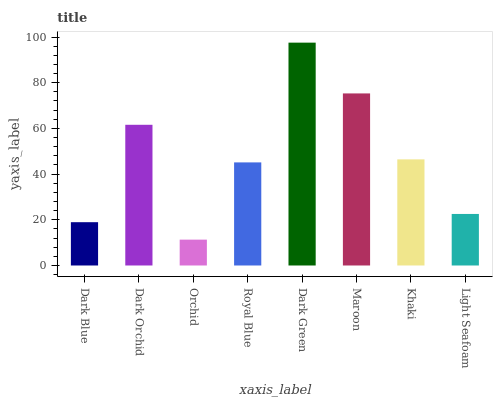Is Orchid the minimum?
Answer yes or no. Yes. Is Dark Green the maximum?
Answer yes or no. Yes. Is Dark Orchid the minimum?
Answer yes or no. No. Is Dark Orchid the maximum?
Answer yes or no. No. Is Dark Orchid greater than Dark Blue?
Answer yes or no. Yes. Is Dark Blue less than Dark Orchid?
Answer yes or no. Yes. Is Dark Blue greater than Dark Orchid?
Answer yes or no. No. Is Dark Orchid less than Dark Blue?
Answer yes or no. No. Is Khaki the high median?
Answer yes or no. Yes. Is Royal Blue the low median?
Answer yes or no. Yes. Is Orchid the high median?
Answer yes or no. No. Is Orchid the low median?
Answer yes or no. No. 